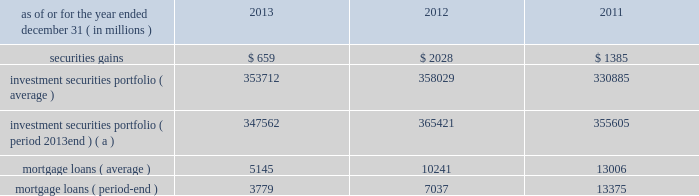Management 2019s discussion and analysis 110 jpmorgan chase & co./2013 annual report 2012 compared with 2011 net loss was $ 2.0 billion , compared with a net income of $ 919 million in the prior year .
Private equity reported net income of $ 292 million , compared with net income of $ 391 million in the prior year .
Net revenue was $ 601 million , compared with $ 836 million in the prior year , due to lower unrealized and realized gains on private investments , partially offset by higher unrealized gains on public securities .
Noninterest expense was $ 145 million , down from $ 238 million in the prior year .
Treasury and cio reported a net loss of $ 2.1 billion , compared with net income of $ 1.3 billion in the prior year .
Net revenue was a loss of $ 3.1 billion , compared with net revenue of $ 3.2 billion in the prior year .
The current year loss reflected $ 5.8 billion of losses incurred by cio from the synthetic credit portfolio for the six months ended june 30 , 2012 , and $ 449 million of losses from the retained index credit derivative positions for the three months ended september 30 , 2012 .
These losses were partially offset by securities gains of $ 2.0 billion .
The current year revenue reflected $ 888 million of extinguishment gains related to the redemption of trust preferred securities , which are included in all other income in the above table .
The extinguishment gains were related to adjustments applied to the cost basis of the trust preferred securities during the period they were in a qualified hedge accounting relationship .
Net interest income was negative $ 683 million , compared with $ 1.4 billion in the prior year , primarily reflecting the impact of lower portfolio yields and higher deposit balances across the firm .
Other corporate reported a net loss of $ 221 million , compared with a net loss of $ 821 million in the prior year .
Noninterest revenue of $ 1.8 billion was driven by a $ 1.1 billion benefit for the washington mutual bankruptcy settlement , which is included in all other income in the above table , and a $ 665 million gain from the recovery on a bear stearns-related subordinated loan .
Noninterest expense of $ 3.8 billion was up $ 1.0 billion compared with the prior year .
The current year included expense of $ 3.7 billion for additional litigation reserves , largely for mortgage-related matters .
The prior year included expense of $ 3.2 billion for additional litigation reserves .
Treasury and cio overview treasury and cio are predominantly responsible for measuring , monitoring , reporting and managing the firm 2019s liquidity , funding and structural interest rate and foreign exchange risks , as well as executing the firm 2019s capital plan .
The risks managed by treasury and cio arise from the activities undertaken by the firm 2019s four major reportable business segments to serve their respective client bases , which generate both on- and off-balance sheet assets and liabilities .
Cio achieves the firm 2019s asset-liability management objectives generally by investing in high-quality securities that are managed for the longer-term as part of the firm 2019s afs and htm investment securities portfolios ( the 201cinvestment securities portfolio 201d ) .
Cio also uses derivatives , as well as securities that are not classified as afs or htm , to meet the firm 2019s asset-liability management objectives .
For further information on derivatives , see note 6 on pages 220 2013233 of this annual report .
For further information about securities not classified within the afs or htm portfolio , see note 3 on pages 195 2013215 of this annual report .
The treasury and cio investment securities portfolio primarily consists of u.s .
And non-u.s .
Government securities , agency and non-agency mortgage-backed securities , other asset-backed securities , corporate debt securities and obligations of u.s .
States and municipalities .
At december 31 , 2013 , the total treasury and cio investment securities portfolio was $ 347.6 billion ; the average credit rating of the securities comprising the treasury and cio investment securities portfolio was aa+ ( based upon external ratings where available and where not available , based primarily upon internal ratings that correspond to ratings as defined by s&p and moody 2019s ) .
See note 12 on pages 249 2013254 of this annual report for further information on the details of the firm 2019s investment securities portfolio .
For further information on liquidity and funding risk , see liquidity risk management on pages 168 2013173 of this annual report .
For information on interest rate , foreign exchange and other risks , treasury and cio value-at-risk ( 201cvar 201d ) and the firm 2019s structural interest rate-sensitive revenue at risk , see market risk management on pages 142 2013148 of this annual report .
Selected income statement and balance sheet data as of or for the year ended december 31 , ( in millions ) 2013 2012 2011 .
( a ) period-end investment securities included held-to-maturity balance of $ 24.0 billion at december 31 , 2013 .
Held-to-maturity balances for the other periods were not material. .
Based on the selected financial statement data what was the variance between the mortgage loans average and period-end balance? 
Computations: (5145 - 3779)
Answer: 1366.0. 